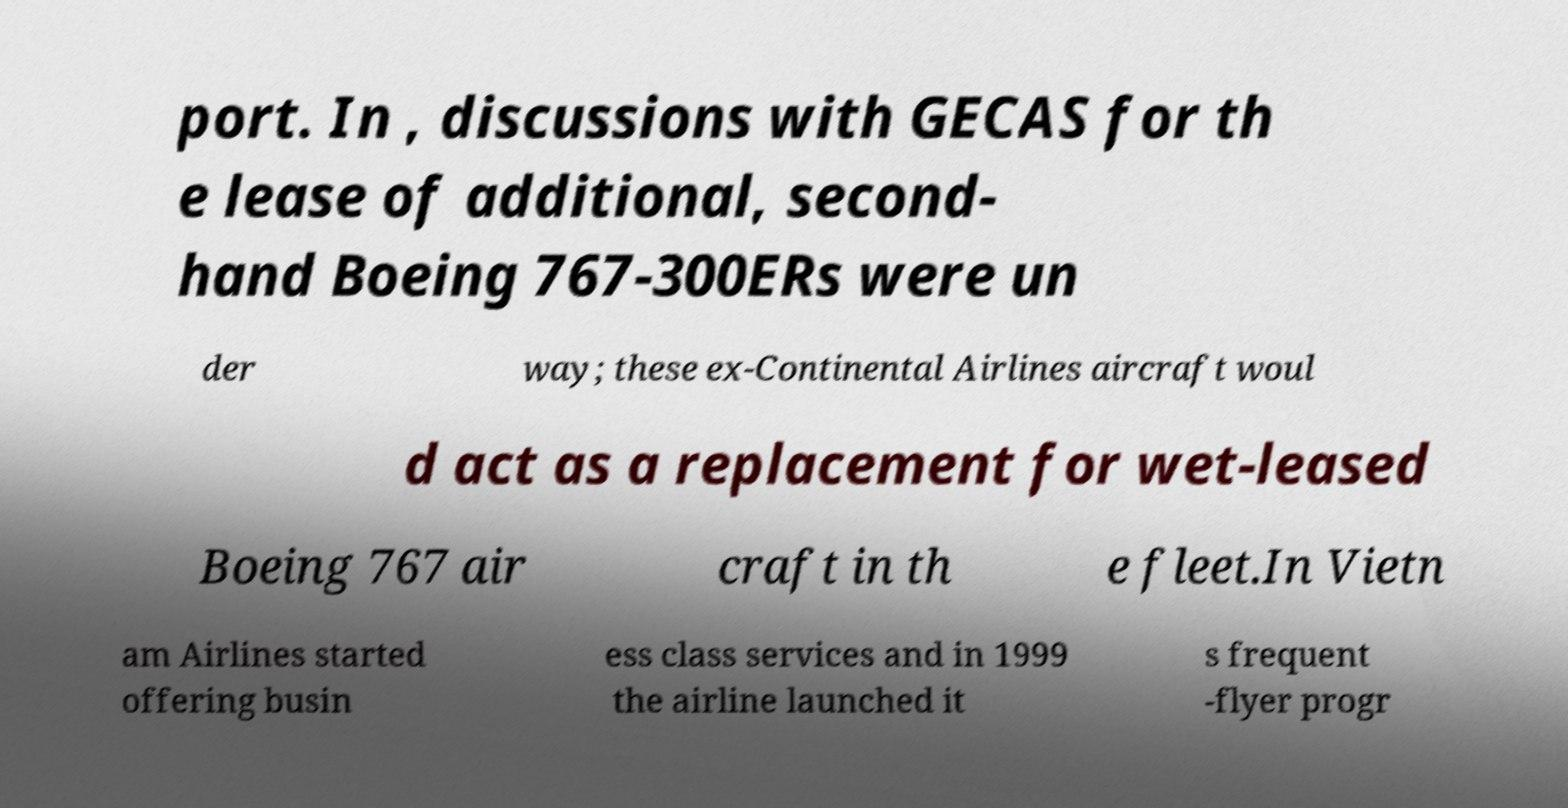Can you read and provide the text displayed in the image?This photo seems to have some interesting text. Can you extract and type it out for me? port. In , discussions with GECAS for th e lease of additional, second- hand Boeing 767-300ERs were un der way; these ex-Continental Airlines aircraft woul d act as a replacement for wet-leased Boeing 767 air craft in th e fleet.In Vietn am Airlines started offering busin ess class services and in 1999 the airline launched it s frequent -flyer progr 